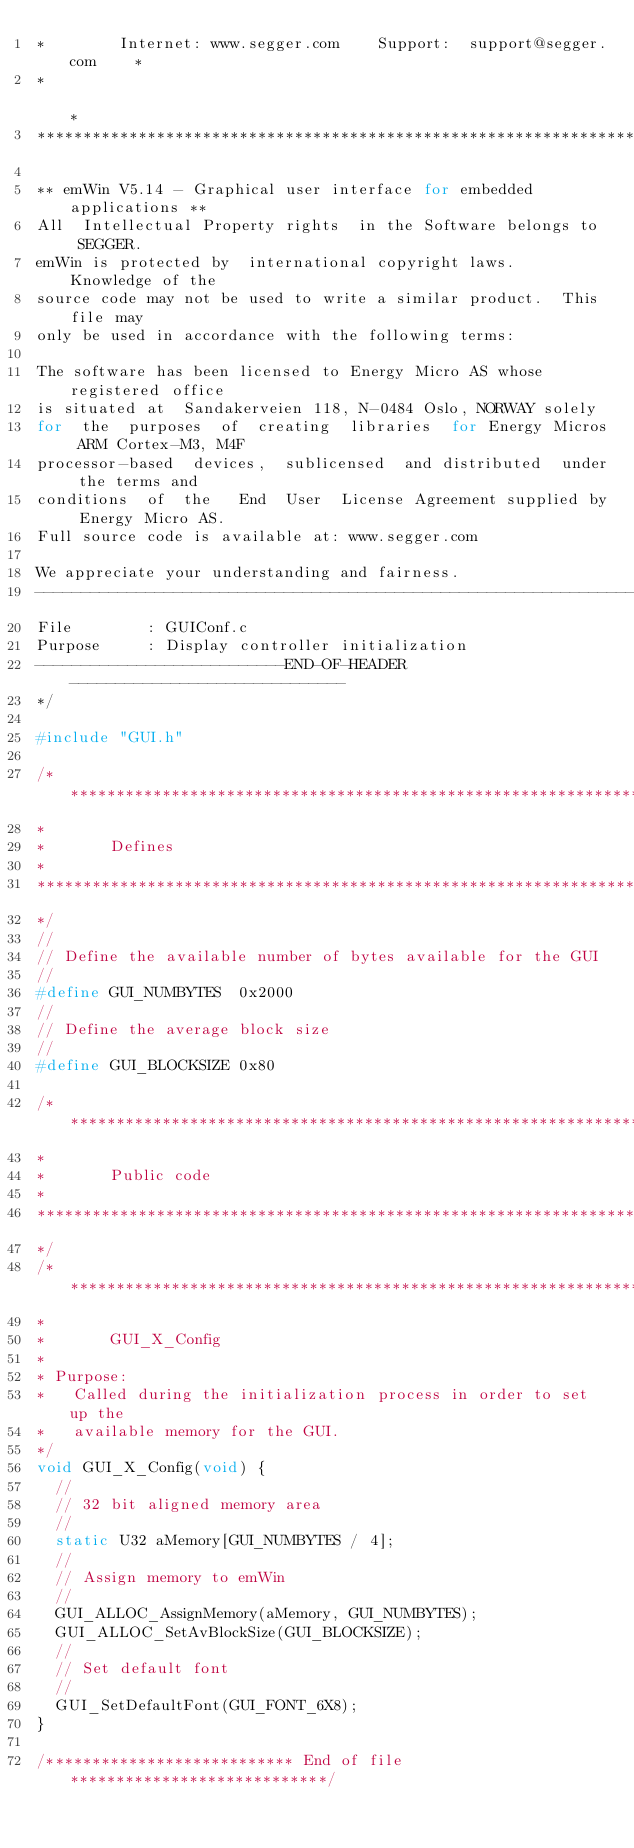<code> <loc_0><loc_0><loc_500><loc_500><_C_>*        Internet: www.segger.com    Support:  support@segger.com    *
*                                                                    *
**********************************************************************

** emWin V5.14 - Graphical user interface for embedded applications **
All  Intellectual Property rights  in the Software belongs to  SEGGER.
emWin is protected by  international copyright laws.  Knowledge of the
source code may not be used to write a similar product.  This file may
only be used in accordance with the following terms:

The software has been licensed to Energy Micro AS whose registered office
is situated at  Sandakerveien 118, N-0484 Oslo, NORWAY solely
for  the  purposes  of  creating  libraries  for Energy Micros ARM Cortex-M3, M4F
processor-based  devices,  sublicensed  and distributed  under the terms and
conditions  of  the   End  User  License Agreement supplied by Energy Micro AS. 
Full source code is available at: www.segger.com

We appreciate your understanding and fairness.
----------------------------------------------------------------------
File        : GUIConf.c
Purpose     : Display controller initialization
---------------------------END-OF-HEADER------------------------------
*/

#include "GUI.h"

/*********************************************************************
*
*       Defines
*
**********************************************************************
*/
//
// Define the available number of bytes available for the GUI
//
#define GUI_NUMBYTES  0x2000
//
// Define the average block size
//
#define GUI_BLOCKSIZE 0x80

/*********************************************************************
*
*       Public code
*
**********************************************************************
*/
/*********************************************************************
*
*       GUI_X_Config
*
* Purpose:
*   Called during the initialization process in order to set up the
*   available memory for the GUI.
*/
void GUI_X_Config(void) {
  //
  // 32 bit aligned memory area
  //
  static U32 aMemory[GUI_NUMBYTES / 4];
  //
  // Assign memory to emWin
  //
  GUI_ALLOC_AssignMemory(aMemory, GUI_NUMBYTES);
  GUI_ALLOC_SetAvBlockSize(GUI_BLOCKSIZE);
  //
  // Set default font
  //
  GUI_SetDefaultFont(GUI_FONT_6X8);
}

/*************************** End of file ****************************/
</code> 